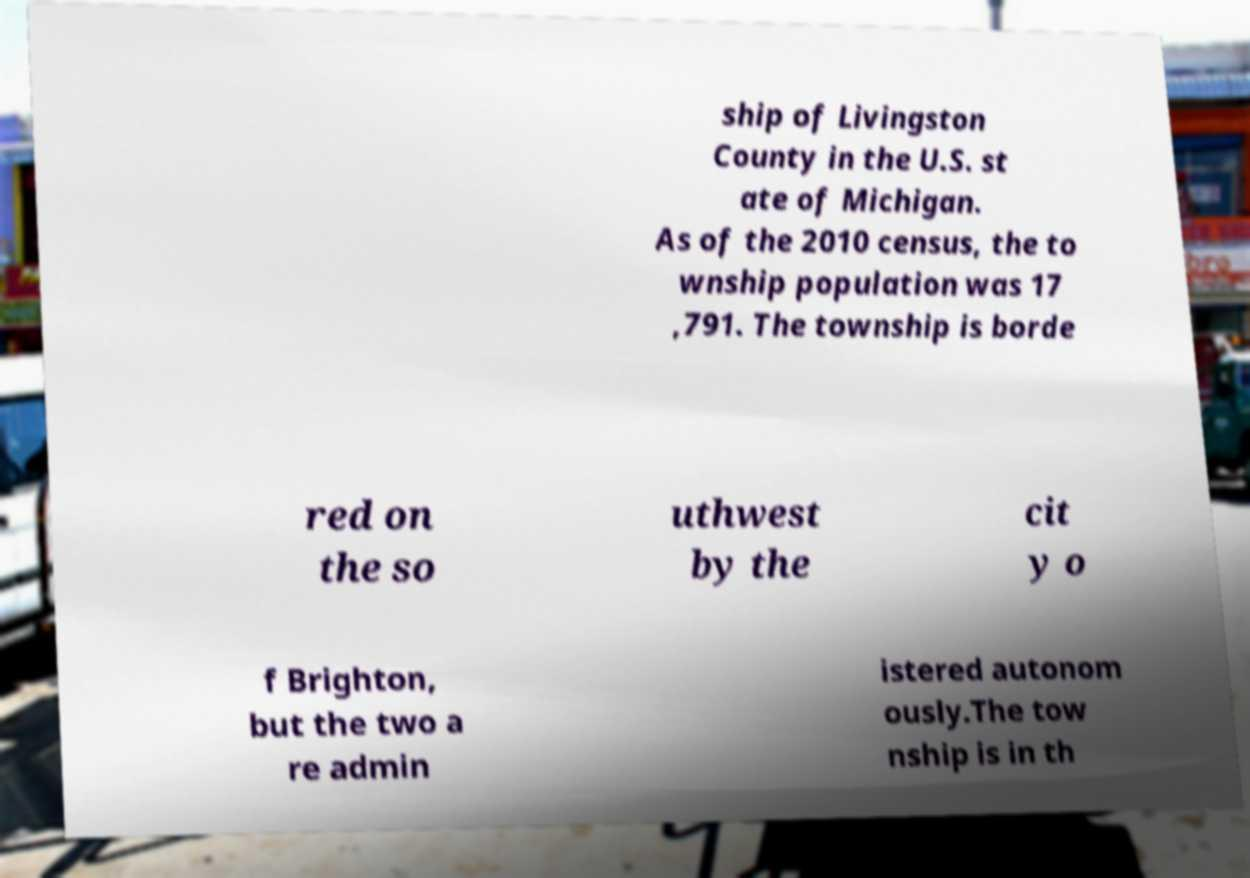Please identify and transcribe the text found in this image. ship of Livingston County in the U.S. st ate of Michigan. As of the 2010 census, the to wnship population was 17 ,791. The township is borde red on the so uthwest by the cit y o f Brighton, but the two a re admin istered autonom ously.The tow nship is in th 